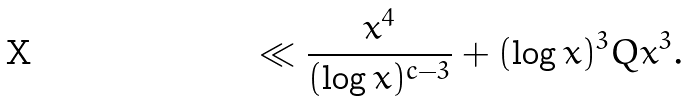<formula> <loc_0><loc_0><loc_500><loc_500>\ll \frac { x ^ { 4 } } { ( \log x ) ^ { c - 3 } } + ( \log x ) ^ { 3 } Q x ^ { 3 } .</formula> 